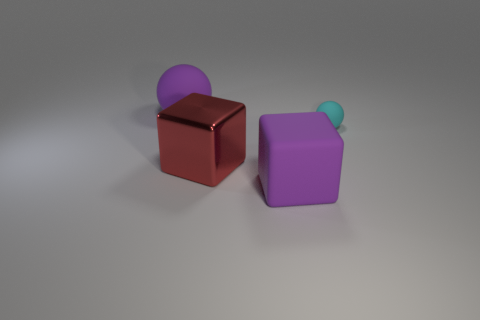Add 4 red blocks. How many objects exist? 8 Subtract all red blocks. How many blocks are left? 1 Subtract 1 balls. How many balls are left? 1 Subtract all yellow blocks. How many purple balls are left? 1 Subtract all metallic objects. Subtract all matte balls. How many objects are left? 1 Add 3 cyan balls. How many cyan balls are left? 4 Add 3 small matte spheres. How many small matte spheres exist? 4 Subtract 0 brown spheres. How many objects are left? 4 Subtract all red spheres. Subtract all blue blocks. How many spheres are left? 2 